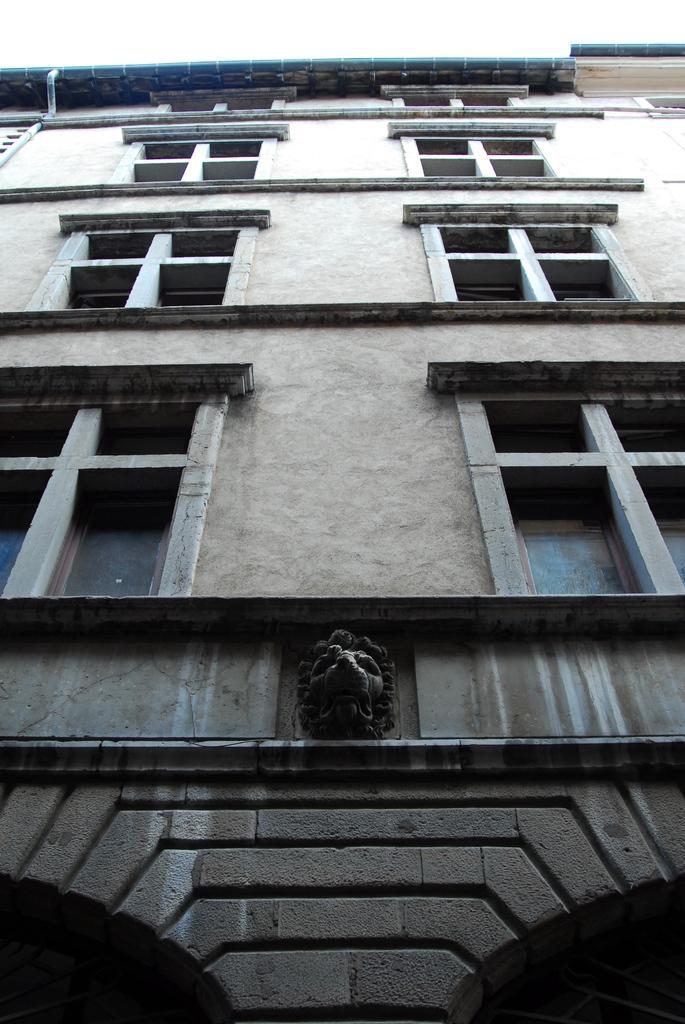Could you give a brief overview of what you see in this image? In this image we can see a building, statue, and windows. 